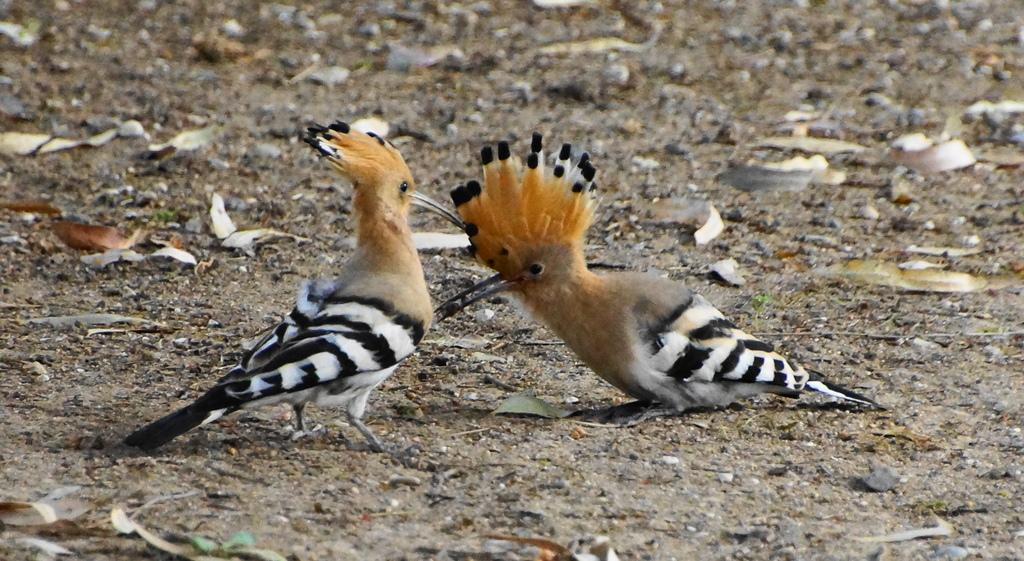How many birds are present in the image? There are two birds in the image. What are the birds doing in the image? The birds are standing on the ground and poking each other with their beaks. What can be seen on the ground in the image? There are stones and dry leaves on the ground in the image. What type of reward is the bird receiving from the parent in the image? There is no reward or parent present in the image; it only features two birds interacting with each other. 